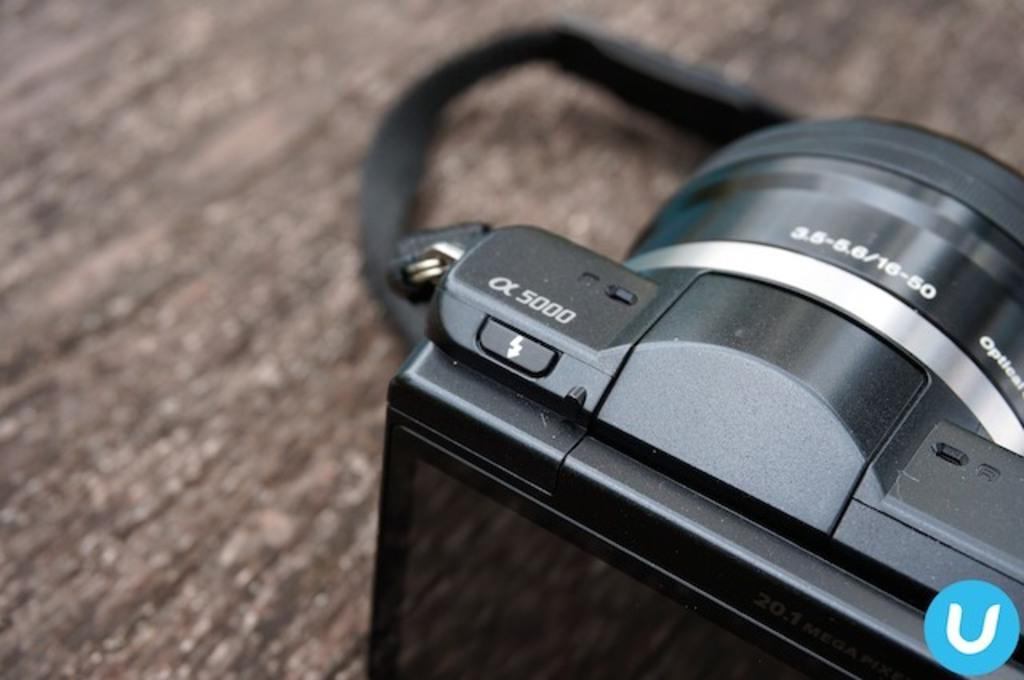What object is located on the table in the image? There is a camera on the table in the image. What additional detail can be seen in the image? There is a logo in the image. Where is the alarm located in the image? There is no alarm present in the image. What type of food is being served in the lunchroom in the image? There is no lunchroom present in the image. 